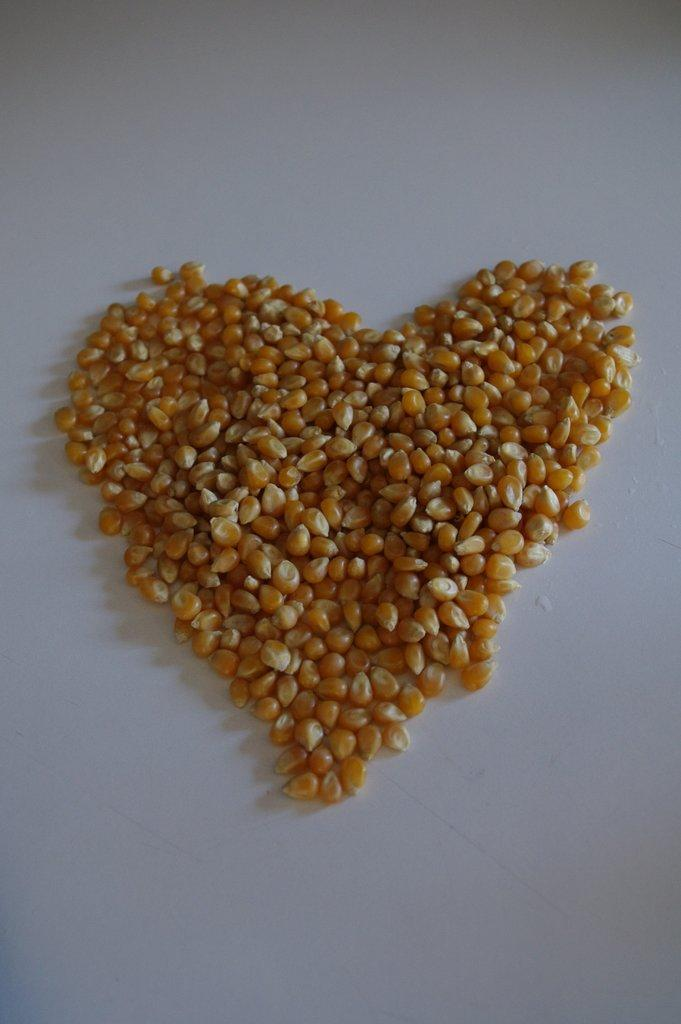What type of food is visible in the image? There are maize grains in the image. What color is the background of the image? The background of the image is white. What type of point is the goose making in the image? There is no goose present in the image, and therefore no point can be made by a goose. 